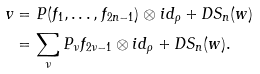Convert formula to latex. <formula><loc_0><loc_0><loc_500><loc_500>v & = P ( f _ { 1 } , \dots , f _ { 2 n - 1 } ) \otimes i d _ { \rho } + D S _ { n } ( w ) \\ & = \sum _ { \nu } P _ { \nu } f _ { 2 \nu - 1 } \otimes i d _ { \rho } + D S _ { n } ( w ) .</formula> 